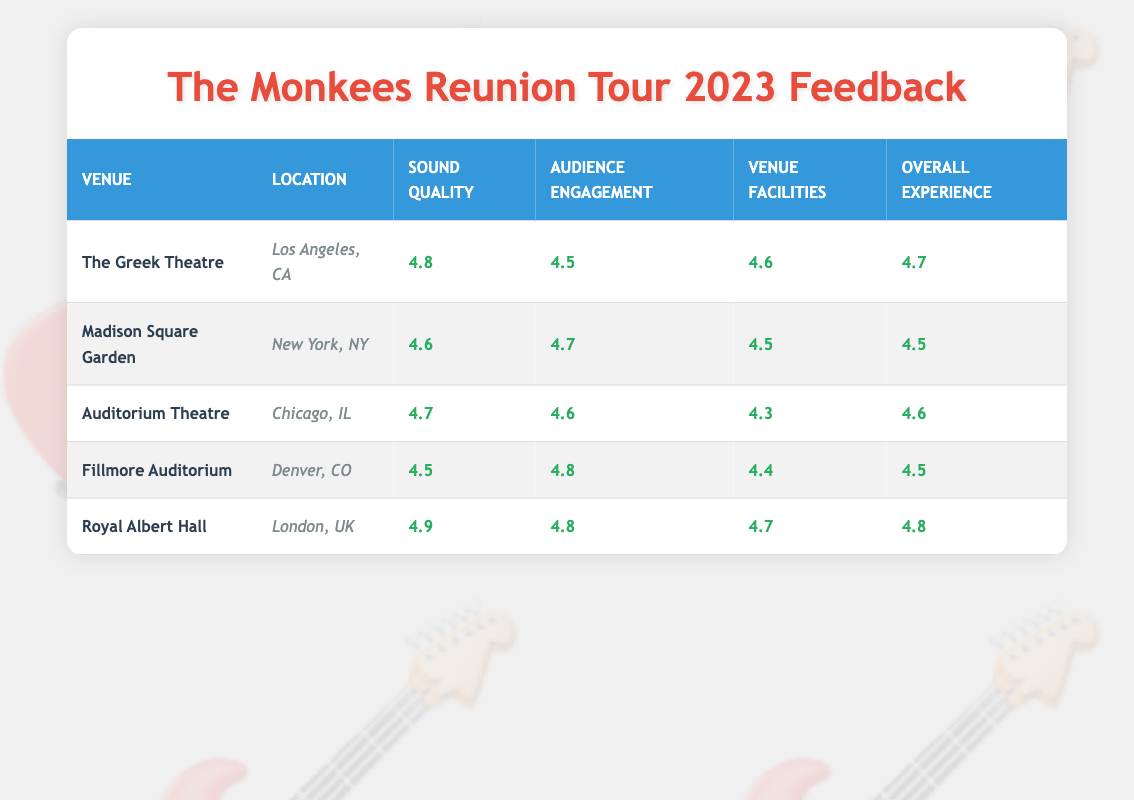What is the highest rating for Sound Quality among the venues? The ratings for Sound Quality are: The Greek Theatre - 4.8, Madison Square Garden - 4.6, Auditorium Theatre - 4.7, Fillmore Auditorium - 4.5, Royal Albert Hall - 4.9. The highest value is 4.9 from Royal Albert Hall.
Answer: 4.9 Which venue received the lowest rating for Venue Facilities? The ratings for Venue Facilities are: The Greek Theatre - 4.6, Madison Square Garden - 4.5, Auditorium Theatre - 4.3, Fillmore Auditorium - 4.4, Royal Albert Hall - 4.7. The lowest value is 4.3 from Auditorium Theatre.
Answer: 4.3 What is the average Overall Experience rating across all the venues? The Overall Experience ratings are: The Greek Theatre - 4.7, Madison Square Garden - 4.5, Auditorium Theatre - 4.6, Fillmore Auditorium - 4.5, Royal Albert Hall - 4.8. Sum these ratings: 4.7 + 4.5 + 4.6 + 4.5 + 4.8 = 23.1. There are 5 venues, so the average is 23.1 / 5 = 4.62.
Answer: 4.62 Did all venues have an Audience Engagement rating of 4.5 or higher? The Audience Engagement ratings are: The Greek Theatre - 4.5, Madison Square Garden - 4.7, Auditorium Theatre - 4.6, Fillmore Auditorium - 4.8, Royal Albert Hall - 4.8. All ratings are 4.5 or higher, confirming that the statement is true.
Answer: Yes Which venue had the best Overall Experience rating and what was the score? The Overall Experience ratings are: The Greek Theatre - 4.7, Madison Square Garden - 4.5, Auditorium Theatre - 4.6, Fillmore Auditorium - 4.5, Royal Albert Hall - 4.8. Royal Albert Hall has the highest rating of 4.8.
Answer: Royal Albert Hall, 4.8 